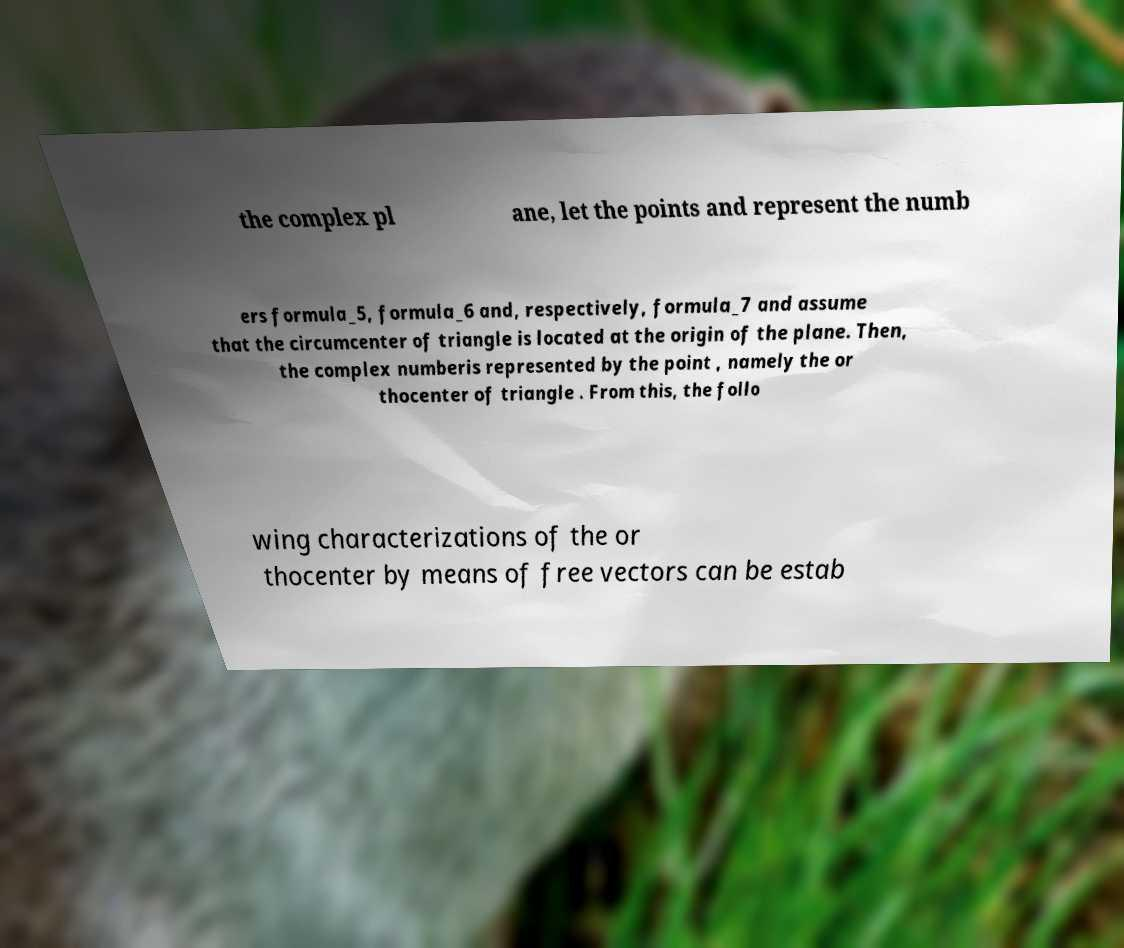For documentation purposes, I need the text within this image transcribed. Could you provide that? the complex pl ane, let the points and represent the numb ers formula_5, formula_6 and, respectively, formula_7 and assume that the circumcenter of triangle is located at the origin of the plane. Then, the complex numberis represented by the point , namely the or thocenter of triangle . From this, the follo wing characterizations of the or thocenter by means of free vectors can be estab 